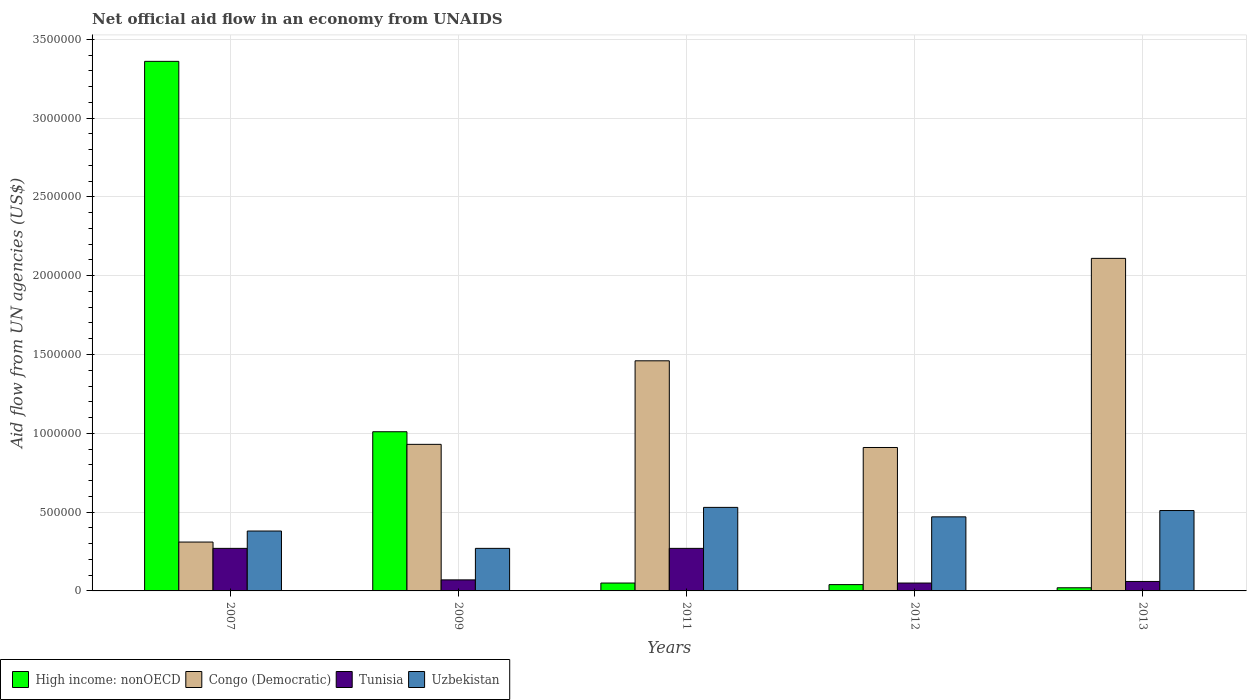How many different coloured bars are there?
Make the answer very short. 4. Are the number of bars per tick equal to the number of legend labels?
Give a very brief answer. Yes. How many bars are there on the 5th tick from the right?
Your answer should be compact. 4. In how many cases, is the number of bars for a given year not equal to the number of legend labels?
Provide a succinct answer. 0. What is the net official aid flow in Uzbekistan in 2009?
Provide a short and direct response. 2.70e+05. Across all years, what is the maximum net official aid flow in Congo (Democratic)?
Make the answer very short. 2.11e+06. Across all years, what is the minimum net official aid flow in Uzbekistan?
Offer a very short reply. 2.70e+05. In which year was the net official aid flow in Congo (Democratic) maximum?
Your response must be concise. 2013. What is the total net official aid flow in Uzbekistan in the graph?
Provide a short and direct response. 2.16e+06. What is the difference between the net official aid flow in Congo (Democratic) in 2009 and that in 2011?
Ensure brevity in your answer.  -5.30e+05. What is the difference between the net official aid flow in High income: nonOECD in 2007 and the net official aid flow in Congo (Democratic) in 2011?
Provide a short and direct response. 1.90e+06. What is the average net official aid flow in Uzbekistan per year?
Offer a terse response. 4.32e+05. What is the ratio of the net official aid flow in Congo (Democratic) in 2011 to that in 2013?
Ensure brevity in your answer.  0.69. What is the difference between the highest and the second highest net official aid flow in Congo (Democratic)?
Keep it short and to the point. 6.50e+05. What is the difference between the highest and the lowest net official aid flow in High income: nonOECD?
Your answer should be very brief. 3.34e+06. In how many years, is the net official aid flow in Uzbekistan greater than the average net official aid flow in Uzbekistan taken over all years?
Keep it short and to the point. 3. Is the sum of the net official aid flow in Congo (Democratic) in 2007 and 2012 greater than the maximum net official aid flow in Tunisia across all years?
Offer a terse response. Yes. Is it the case that in every year, the sum of the net official aid flow in Tunisia and net official aid flow in High income: nonOECD is greater than the sum of net official aid flow in Uzbekistan and net official aid flow in Congo (Democratic)?
Provide a succinct answer. No. What does the 4th bar from the left in 2009 represents?
Provide a short and direct response. Uzbekistan. What does the 3rd bar from the right in 2013 represents?
Make the answer very short. Congo (Democratic). How many bars are there?
Offer a very short reply. 20. What is the difference between two consecutive major ticks on the Y-axis?
Your answer should be very brief. 5.00e+05. Are the values on the major ticks of Y-axis written in scientific E-notation?
Provide a succinct answer. No. Does the graph contain grids?
Your answer should be very brief. Yes. Where does the legend appear in the graph?
Your response must be concise. Bottom left. What is the title of the graph?
Your answer should be compact. Net official aid flow in an economy from UNAIDS. Does "Botswana" appear as one of the legend labels in the graph?
Give a very brief answer. No. What is the label or title of the X-axis?
Provide a short and direct response. Years. What is the label or title of the Y-axis?
Your answer should be very brief. Aid flow from UN agencies (US$). What is the Aid flow from UN agencies (US$) in High income: nonOECD in 2007?
Offer a terse response. 3.36e+06. What is the Aid flow from UN agencies (US$) of High income: nonOECD in 2009?
Ensure brevity in your answer.  1.01e+06. What is the Aid flow from UN agencies (US$) of Congo (Democratic) in 2009?
Your answer should be compact. 9.30e+05. What is the Aid flow from UN agencies (US$) in Uzbekistan in 2009?
Make the answer very short. 2.70e+05. What is the Aid flow from UN agencies (US$) in Congo (Democratic) in 2011?
Your answer should be compact. 1.46e+06. What is the Aid flow from UN agencies (US$) of Tunisia in 2011?
Ensure brevity in your answer.  2.70e+05. What is the Aid flow from UN agencies (US$) of Uzbekistan in 2011?
Make the answer very short. 5.30e+05. What is the Aid flow from UN agencies (US$) of Congo (Democratic) in 2012?
Provide a short and direct response. 9.10e+05. What is the Aid flow from UN agencies (US$) of Uzbekistan in 2012?
Provide a succinct answer. 4.70e+05. What is the Aid flow from UN agencies (US$) of Congo (Democratic) in 2013?
Offer a very short reply. 2.11e+06. What is the Aid flow from UN agencies (US$) in Uzbekistan in 2013?
Give a very brief answer. 5.10e+05. Across all years, what is the maximum Aid flow from UN agencies (US$) in High income: nonOECD?
Give a very brief answer. 3.36e+06. Across all years, what is the maximum Aid flow from UN agencies (US$) of Congo (Democratic)?
Provide a short and direct response. 2.11e+06. Across all years, what is the maximum Aid flow from UN agencies (US$) of Uzbekistan?
Your answer should be very brief. 5.30e+05. Across all years, what is the minimum Aid flow from UN agencies (US$) of High income: nonOECD?
Offer a terse response. 2.00e+04. Across all years, what is the minimum Aid flow from UN agencies (US$) of Congo (Democratic)?
Offer a terse response. 3.10e+05. What is the total Aid flow from UN agencies (US$) of High income: nonOECD in the graph?
Give a very brief answer. 4.48e+06. What is the total Aid flow from UN agencies (US$) of Congo (Democratic) in the graph?
Your answer should be compact. 5.72e+06. What is the total Aid flow from UN agencies (US$) in Tunisia in the graph?
Provide a succinct answer. 7.20e+05. What is the total Aid flow from UN agencies (US$) of Uzbekistan in the graph?
Offer a terse response. 2.16e+06. What is the difference between the Aid flow from UN agencies (US$) of High income: nonOECD in 2007 and that in 2009?
Make the answer very short. 2.35e+06. What is the difference between the Aid flow from UN agencies (US$) in Congo (Democratic) in 2007 and that in 2009?
Make the answer very short. -6.20e+05. What is the difference between the Aid flow from UN agencies (US$) in Tunisia in 2007 and that in 2009?
Make the answer very short. 2.00e+05. What is the difference between the Aid flow from UN agencies (US$) in High income: nonOECD in 2007 and that in 2011?
Your answer should be very brief. 3.31e+06. What is the difference between the Aid flow from UN agencies (US$) in Congo (Democratic) in 2007 and that in 2011?
Provide a succinct answer. -1.15e+06. What is the difference between the Aid flow from UN agencies (US$) in Tunisia in 2007 and that in 2011?
Provide a short and direct response. 0. What is the difference between the Aid flow from UN agencies (US$) in Uzbekistan in 2007 and that in 2011?
Provide a succinct answer. -1.50e+05. What is the difference between the Aid flow from UN agencies (US$) of High income: nonOECD in 2007 and that in 2012?
Offer a terse response. 3.32e+06. What is the difference between the Aid flow from UN agencies (US$) in Congo (Democratic) in 2007 and that in 2012?
Give a very brief answer. -6.00e+05. What is the difference between the Aid flow from UN agencies (US$) of Tunisia in 2007 and that in 2012?
Ensure brevity in your answer.  2.20e+05. What is the difference between the Aid flow from UN agencies (US$) of High income: nonOECD in 2007 and that in 2013?
Give a very brief answer. 3.34e+06. What is the difference between the Aid flow from UN agencies (US$) of Congo (Democratic) in 2007 and that in 2013?
Offer a very short reply. -1.80e+06. What is the difference between the Aid flow from UN agencies (US$) of High income: nonOECD in 2009 and that in 2011?
Offer a terse response. 9.60e+05. What is the difference between the Aid flow from UN agencies (US$) in Congo (Democratic) in 2009 and that in 2011?
Offer a terse response. -5.30e+05. What is the difference between the Aid flow from UN agencies (US$) in Tunisia in 2009 and that in 2011?
Make the answer very short. -2.00e+05. What is the difference between the Aid flow from UN agencies (US$) in Uzbekistan in 2009 and that in 2011?
Keep it short and to the point. -2.60e+05. What is the difference between the Aid flow from UN agencies (US$) in High income: nonOECD in 2009 and that in 2012?
Your answer should be very brief. 9.70e+05. What is the difference between the Aid flow from UN agencies (US$) in Congo (Democratic) in 2009 and that in 2012?
Provide a succinct answer. 2.00e+04. What is the difference between the Aid flow from UN agencies (US$) of Tunisia in 2009 and that in 2012?
Offer a terse response. 2.00e+04. What is the difference between the Aid flow from UN agencies (US$) in Uzbekistan in 2009 and that in 2012?
Your response must be concise. -2.00e+05. What is the difference between the Aid flow from UN agencies (US$) of High income: nonOECD in 2009 and that in 2013?
Provide a short and direct response. 9.90e+05. What is the difference between the Aid flow from UN agencies (US$) of Congo (Democratic) in 2009 and that in 2013?
Your answer should be very brief. -1.18e+06. What is the difference between the Aid flow from UN agencies (US$) in Uzbekistan in 2009 and that in 2013?
Offer a terse response. -2.40e+05. What is the difference between the Aid flow from UN agencies (US$) of Tunisia in 2011 and that in 2012?
Your answer should be compact. 2.20e+05. What is the difference between the Aid flow from UN agencies (US$) of Uzbekistan in 2011 and that in 2012?
Give a very brief answer. 6.00e+04. What is the difference between the Aid flow from UN agencies (US$) in High income: nonOECD in 2011 and that in 2013?
Ensure brevity in your answer.  3.00e+04. What is the difference between the Aid flow from UN agencies (US$) in Congo (Democratic) in 2011 and that in 2013?
Provide a short and direct response. -6.50e+05. What is the difference between the Aid flow from UN agencies (US$) in Tunisia in 2011 and that in 2013?
Your answer should be very brief. 2.10e+05. What is the difference between the Aid flow from UN agencies (US$) in High income: nonOECD in 2012 and that in 2013?
Keep it short and to the point. 2.00e+04. What is the difference between the Aid flow from UN agencies (US$) in Congo (Democratic) in 2012 and that in 2013?
Provide a succinct answer. -1.20e+06. What is the difference between the Aid flow from UN agencies (US$) of Tunisia in 2012 and that in 2013?
Ensure brevity in your answer.  -10000. What is the difference between the Aid flow from UN agencies (US$) of High income: nonOECD in 2007 and the Aid flow from UN agencies (US$) of Congo (Democratic) in 2009?
Your answer should be very brief. 2.43e+06. What is the difference between the Aid flow from UN agencies (US$) of High income: nonOECD in 2007 and the Aid flow from UN agencies (US$) of Tunisia in 2009?
Give a very brief answer. 3.29e+06. What is the difference between the Aid flow from UN agencies (US$) of High income: nonOECD in 2007 and the Aid flow from UN agencies (US$) of Uzbekistan in 2009?
Offer a very short reply. 3.09e+06. What is the difference between the Aid flow from UN agencies (US$) of Congo (Democratic) in 2007 and the Aid flow from UN agencies (US$) of Uzbekistan in 2009?
Offer a very short reply. 4.00e+04. What is the difference between the Aid flow from UN agencies (US$) of High income: nonOECD in 2007 and the Aid flow from UN agencies (US$) of Congo (Democratic) in 2011?
Your response must be concise. 1.90e+06. What is the difference between the Aid flow from UN agencies (US$) in High income: nonOECD in 2007 and the Aid flow from UN agencies (US$) in Tunisia in 2011?
Provide a succinct answer. 3.09e+06. What is the difference between the Aid flow from UN agencies (US$) of High income: nonOECD in 2007 and the Aid flow from UN agencies (US$) of Uzbekistan in 2011?
Provide a short and direct response. 2.83e+06. What is the difference between the Aid flow from UN agencies (US$) of Congo (Democratic) in 2007 and the Aid flow from UN agencies (US$) of Uzbekistan in 2011?
Keep it short and to the point. -2.20e+05. What is the difference between the Aid flow from UN agencies (US$) of Tunisia in 2007 and the Aid flow from UN agencies (US$) of Uzbekistan in 2011?
Ensure brevity in your answer.  -2.60e+05. What is the difference between the Aid flow from UN agencies (US$) of High income: nonOECD in 2007 and the Aid flow from UN agencies (US$) of Congo (Democratic) in 2012?
Provide a short and direct response. 2.45e+06. What is the difference between the Aid flow from UN agencies (US$) of High income: nonOECD in 2007 and the Aid flow from UN agencies (US$) of Tunisia in 2012?
Your answer should be very brief. 3.31e+06. What is the difference between the Aid flow from UN agencies (US$) in High income: nonOECD in 2007 and the Aid flow from UN agencies (US$) in Uzbekistan in 2012?
Give a very brief answer. 2.89e+06. What is the difference between the Aid flow from UN agencies (US$) in Congo (Democratic) in 2007 and the Aid flow from UN agencies (US$) in Tunisia in 2012?
Give a very brief answer. 2.60e+05. What is the difference between the Aid flow from UN agencies (US$) in Congo (Democratic) in 2007 and the Aid flow from UN agencies (US$) in Uzbekistan in 2012?
Your response must be concise. -1.60e+05. What is the difference between the Aid flow from UN agencies (US$) of High income: nonOECD in 2007 and the Aid flow from UN agencies (US$) of Congo (Democratic) in 2013?
Provide a succinct answer. 1.25e+06. What is the difference between the Aid flow from UN agencies (US$) in High income: nonOECD in 2007 and the Aid flow from UN agencies (US$) in Tunisia in 2013?
Offer a very short reply. 3.30e+06. What is the difference between the Aid flow from UN agencies (US$) in High income: nonOECD in 2007 and the Aid flow from UN agencies (US$) in Uzbekistan in 2013?
Offer a very short reply. 2.85e+06. What is the difference between the Aid flow from UN agencies (US$) of Congo (Democratic) in 2007 and the Aid flow from UN agencies (US$) of Tunisia in 2013?
Ensure brevity in your answer.  2.50e+05. What is the difference between the Aid flow from UN agencies (US$) of High income: nonOECD in 2009 and the Aid flow from UN agencies (US$) of Congo (Democratic) in 2011?
Make the answer very short. -4.50e+05. What is the difference between the Aid flow from UN agencies (US$) in High income: nonOECD in 2009 and the Aid flow from UN agencies (US$) in Tunisia in 2011?
Offer a very short reply. 7.40e+05. What is the difference between the Aid flow from UN agencies (US$) of Congo (Democratic) in 2009 and the Aid flow from UN agencies (US$) of Tunisia in 2011?
Ensure brevity in your answer.  6.60e+05. What is the difference between the Aid flow from UN agencies (US$) of Tunisia in 2009 and the Aid flow from UN agencies (US$) of Uzbekistan in 2011?
Your answer should be very brief. -4.60e+05. What is the difference between the Aid flow from UN agencies (US$) of High income: nonOECD in 2009 and the Aid flow from UN agencies (US$) of Tunisia in 2012?
Keep it short and to the point. 9.60e+05. What is the difference between the Aid flow from UN agencies (US$) in High income: nonOECD in 2009 and the Aid flow from UN agencies (US$) in Uzbekistan in 2012?
Give a very brief answer. 5.40e+05. What is the difference between the Aid flow from UN agencies (US$) in Congo (Democratic) in 2009 and the Aid flow from UN agencies (US$) in Tunisia in 2012?
Provide a short and direct response. 8.80e+05. What is the difference between the Aid flow from UN agencies (US$) in Congo (Democratic) in 2009 and the Aid flow from UN agencies (US$) in Uzbekistan in 2012?
Ensure brevity in your answer.  4.60e+05. What is the difference between the Aid flow from UN agencies (US$) of Tunisia in 2009 and the Aid flow from UN agencies (US$) of Uzbekistan in 2012?
Provide a succinct answer. -4.00e+05. What is the difference between the Aid flow from UN agencies (US$) of High income: nonOECD in 2009 and the Aid flow from UN agencies (US$) of Congo (Democratic) in 2013?
Ensure brevity in your answer.  -1.10e+06. What is the difference between the Aid flow from UN agencies (US$) in High income: nonOECD in 2009 and the Aid flow from UN agencies (US$) in Tunisia in 2013?
Make the answer very short. 9.50e+05. What is the difference between the Aid flow from UN agencies (US$) of Congo (Democratic) in 2009 and the Aid flow from UN agencies (US$) of Tunisia in 2013?
Provide a succinct answer. 8.70e+05. What is the difference between the Aid flow from UN agencies (US$) in Congo (Democratic) in 2009 and the Aid flow from UN agencies (US$) in Uzbekistan in 2013?
Give a very brief answer. 4.20e+05. What is the difference between the Aid flow from UN agencies (US$) of Tunisia in 2009 and the Aid flow from UN agencies (US$) of Uzbekistan in 2013?
Provide a short and direct response. -4.40e+05. What is the difference between the Aid flow from UN agencies (US$) of High income: nonOECD in 2011 and the Aid flow from UN agencies (US$) of Congo (Democratic) in 2012?
Give a very brief answer. -8.60e+05. What is the difference between the Aid flow from UN agencies (US$) in High income: nonOECD in 2011 and the Aid flow from UN agencies (US$) in Uzbekistan in 2012?
Offer a very short reply. -4.20e+05. What is the difference between the Aid flow from UN agencies (US$) in Congo (Democratic) in 2011 and the Aid flow from UN agencies (US$) in Tunisia in 2012?
Provide a succinct answer. 1.41e+06. What is the difference between the Aid flow from UN agencies (US$) in Congo (Democratic) in 2011 and the Aid flow from UN agencies (US$) in Uzbekistan in 2012?
Your answer should be compact. 9.90e+05. What is the difference between the Aid flow from UN agencies (US$) in High income: nonOECD in 2011 and the Aid flow from UN agencies (US$) in Congo (Democratic) in 2013?
Your answer should be very brief. -2.06e+06. What is the difference between the Aid flow from UN agencies (US$) of High income: nonOECD in 2011 and the Aid flow from UN agencies (US$) of Tunisia in 2013?
Your answer should be very brief. -10000. What is the difference between the Aid flow from UN agencies (US$) of High income: nonOECD in 2011 and the Aid flow from UN agencies (US$) of Uzbekistan in 2013?
Offer a terse response. -4.60e+05. What is the difference between the Aid flow from UN agencies (US$) in Congo (Democratic) in 2011 and the Aid flow from UN agencies (US$) in Tunisia in 2013?
Make the answer very short. 1.40e+06. What is the difference between the Aid flow from UN agencies (US$) in Congo (Democratic) in 2011 and the Aid flow from UN agencies (US$) in Uzbekistan in 2013?
Make the answer very short. 9.50e+05. What is the difference between the Aid flow from UN agencies (US$) in High income: nonOECD in 2012 and the Aid flow from UN agencies (US$) in Congo (Democratic) in 2013?
Provide a short and direct response. -2.07e+06. What is the difference between the Aid flow from UN agencies (US$) of High income: nonOECD in 2012 and the Aid flow from UN agencies (US$) of Uzbekistan in 2013?
Give a very brief answer. -4.70e+05. What is the difference between the Aid flow from UN agencies (US$) of Congo (Democratic) in 2012 and the Aid flow from UN agencies (US$) of Tunisia in 2013?
Your answer should be very brief. 8.50e+05. What is the difference between the Aid flow from UN agencies (US$) in Tunisia in 2012 and the Aid flow from UN agencies (US$) in Uzbekistan in 2013?
Make the answer very short. -4.60e+05. What is the average Aid flow from UN agencies (US$) in High income: nonOECD per year?
Provide a short and direct response. 8.96e+05. What is the average Aid flow from UN agencies (US$) of Congo (Democratic) per year?
Give a very brief answer. 1.14e+06. What is the average Aid flow from UN agencies (US$) of Tunisia per year?
Provide a succinct answer. 1.44e+05. What is the average Aid flow from UN agencies (US$) of Uzbekistan per year?
Give a very brief answer. 4.32e+05. In the year 2007, what is the difference between the Aid flow from UN agencies (US$) of High income: nonOECD and Aid flow from UN agencies (US$) of Congo (Democratic)?
Your answer should be compact. 3.05e+06. In the year 2007, what is the difference between the Aid flow from UN agencies (US$) of High income: nonOECD and Aid flow from UN agencies (US$) of Tunisia?
Your response must be concise. 3.09e+06. In the year 2007, what is the difference between the Aid flow from UN agencies (US$) of High income: nonOECD and Aid flow from UN agencies (US$) of Uzbekistan?
Your answer should be very brief. 2.98e+06. In the year 2007, what is the difference between the Aid flow from UN agencies (US$) of Congo (Democratic) and Aid flow from UN agencies (US$) of Tunisia?
Give a very brief answer. 4.00e+04. In the year 2007, what is the difference between the Aid flow from UN agencies (US$) of Congo (Democratic) and Aid flow from UN agencies (US$) of Uzbekistan?
Give a very brief answer. -7.00e+04. In the year 2007, what is the difference between the Aid flow from UN agencies (US$) of Tunisia and Aid flow from UN agencies (US$) of Uzbekistan?
Offer a very short reply. -1.10e+05. In the year 2009, what is the difference between the Aid flow from UN agencies (US$) of High income: nonOECD and Aid flow from UN agencies (US$) of Tunisia?
Keep it short and to the point. 9.40e+05. In the year 2009, what is the difference between the Aid flow from UN agencies (US$) of High income: nonOECD and Aid flow from UN agencies (US$) of Uzbekistan?
Provide a short and direct response. 7.40e+05. In the year 2009, what is the difference between the Aid flow from UN agencies (US$) of Congo (Democratic) and Aid flow from UN agencies (US$) of Tunisia?
Offer a very short reply. 8.60e+05. In the year 2009, what is the difference between the Aid flow from UN agencies (US$) of Congo (Democratic) and Aid flow from UN agencies (US$) of Uzbekistan?
Your answer should be very brief. 6.60e+05. In the year 2011, what is the difference between the Aid flow from UN agencies (US$) in High income: nonOECD and Aid flow from UN agencies (US$) in Congo (Democratic)?
Give a very brief answer. -1.41e+06. In the year 2011, what is the difference between the Aid flow from UN agencies (US$) in High income: nonOECD and Aid flow from UN agencies (US$) in Tunisia?
Your answer should be very brief. -2.20e+05. In the year 2011, what is the difference between the Aid flow from UN agencies (US$) of High income: nonOECD and Aid flow from UN agencies (US$) of Uzbekistan?
Your response must be concise. -4.80e+05. In the year 2011, what is the difference between the Aid flow from UN agencies (US$) of Congo (Democratic) and Aid flow from UN agencies (US$) of Tunisia?
Your answer should be compact. 1.19e+06. In the year 2011, what is the difference between the Aid flow from UN agencies (US$) of Congo (Democratic) and Aid flow from UN agencies (US$) of Uzbekistan?
Provide a short and direct response. 9.30e+05. In the year 2011, what is the difference between the Aid flow from UN agencies (US$) in Tunisia and Aid flow from UN agencies (US$) in Uzbekistan?
Your answer should be compact. -2.60e+05. In the year 2012, what is the difference between the Aid flow from UN agencies (US$) in High income: nonOECD and Aid flow from UN agencies (US$) in Congo (Democratic)?
Make the answer very short. -8.70e+05. In the year 2012, what is the difference between the Aid flow from UN agencies (US$) of High income: nonOECD and Aid flow from UN agencies (US$) of Uzbekistan?
Give a very brief answer. -4.30e+05. In the year 2012, what is the difference between the Aid flow from UN agencies (US$) in Congo (Democratic) and Aid flow from UN agencies (US$) in Tunisia?
Offer a terse response. 8.60e+05. In the year 2012, what is the difference between the Aid flow from UN agencies (US$) in Congo (Democratic) and Aid flow from UN agencies (US$) in Uzbekistan?
Make the answer very short. 4.40e+05. In the year 2012, what is the difference between the Aid flow from UN agencies (US$) of Tunisia and Aid flow from UN agencies (US$) of Uzbekistan?
Your answer should be compact. -4.20e+05. In the year 2013, what is the difference between the Aid flow from UN agencies (US$) of High income: nonOECD and Aid flow from UN agencies (US$) of Congo (Democratic)?
Your answer should be compact. -2.09e+06. In the year 2013, what is the difference between the Aid flow from UN agencies (US$) in High income: nonOECD and Aid flow from UN agencies (US$) in Tunisia?
Provide a succinct answer. -4.00e+04. In the year 2013, what is the difference between the Aid flow from UN agencies (US$) in High income: nonOECD and Aid flow from UN agencies (US$) in Uzbekistan?
Your response must be concise. -4.90e+05. In the year 2013, what is the difference between the Aid flow from UN agencies (US$) in Congo (Democratic) and Aid flow from UN agencies (US$) in Tunisia?
Offer a very short reply. 2.05e+06. In the year 2013, what is the difference between the Aid flow from UN agencies (US$) of Congo (Democratic) and Aid flow from UN agencies (US$) of Uzbekistan?
Offer a terse response. 1.60e+06. In the year 2013, what is the difference between the Aid flow from UN agencies (US$) of Tunisia and Aid flow from UN agencies (US$) of Uzbekistan?
Your answer should be very brief. -4.50e+05. What is the ratio of the Aid flow from UN agencies (US$) of High income: nonOECD in 2007 to that in 2009?
Give a very brief answer. 3.33. What is the ratio of the Aid flow from UN agencies (US$) of Congo (Democratic) in 2007 to that in 2009?
Make the answer very short. 0.33. What is the ratio of the Aid flow from UN agencies (US$) in Tunisia in 2007 to that in 2009?
Your answer should be compact. 3.86. What is the ratio of the Aid flow from UN agencies (US$) of Uzbekistan in 2007 to that in 2009?
Your response must be concise. 1.41. What is the ratio of the Aid flow from UN agencies (US$) of High income: nonOECD in 2007 to that in 2011?
Provide a short and direct response. 67.2. What is the ratio of the Aid flow from UN agencies (US$) of Congo (Democratic) in 2007 to that in 2011?
Give a very brief answer. 0.21. What is the ratio of the Aid flow from UN agencies (US$) in Uzbekistan in 2007 to that in 2011?
Give a very brief answer. 0.72. What is the ratio of the Aid flow from UN agencies (US$) in High income: nonOECD in 2007 to that in 2012?
Give a very brief answer. 84. What is the ratio of the Aid flow from UN agencies (US$) of Congo (Democratic) in 2007 to that in 2012?
Your answer should be compact. 0.34. What is the ratio of the Aid flow from UN agencies (US$) of Uzbekistan in 2007 to that in 2012?
Your answer should be compact. 0.81. What is the ratio of the Aid flow from UN agencies (US$) in High income: nonOECD in 2007 to that in 2013?
Your answer should be very brief. 168. What is the ratio of the Aid flow from UN agencies (US$) of Congo (Democratic) in 2007 to that in 2013?
Your answer should be very brief. 0.15. What is the ratio of the Aid flow from UN agencies (US$) in Uzbekistan in 2007 to that in 2013?
Offer a terse response. 0.75. What is the ratio of the Aid flow from UN agencies (US$) of High income: nonOECD in 2009 to that in 2011?
Keep it short and to the point. 20.2. What is the ratio of the Aid flow from UN agencies (US$) in Congo (Democratic) in 2009 to that in 2011?
Offer a terse response. 0.64. What is the ratio of the Aid flow from UN agencies (US$) of Tunisia in 2009 to that in 2011?
Your answer should be very brief. 0.26. What is the ratio of the Aid flow from UN agencies (US$) in Uzbekistan in 2009 to that in 2011?
Your answer should be very brief. 0.51. What is the ratio of the Aid flow from UN agencies (US$) in High income: nonOECD in 2009 to that in 2012?
Provide a succinct answer. 25.25. What is the ratio of the Aid flow from UN agencies (US$) of Uzbekistan in 2009 to that in 2012?
Your response must be concise. 0.57. What is the ratio of the Aid flow from UN agencies (US$) of High income: nonOECD in 2009 to that in 2013?
Ensure brevity in your answer.  50.5. What is the ratio of the Aid flow from UN agencies (US$) of Congo (Democratic) in 2009 to that in 2013?
Your answer should be compact. 0.44. What is the ratio of the Aid flow from UN agencies (US$) in Uzbekistan in 2009 to that in 2013?
Offer a terse response. 0.53. What is the ratio of the Aid flow from UN agencies (US$) of Congo (Democratic) in 2011 to that in 2012?
Keep it short and to the point. 1.6. What is the ratio of the Aid flow from UN agencies (US$) of Tunisia in 2011 to that in 2012?
Your answer should be compact. 5.4. What is the ratio of the Aid flow from UN agencies (US$) in Uzbekistan in 2011 to that in 2012?
Offer a terse response. 1.13. What is the ratio of the Aid flow from UN agencies (US$) in High income: nonOECD in 2011 to that in 2013?
Your response must be concise. 2.5. What is the ratio of the Aid flow from UN agencies (US$) of Congo (Democratic) in 2011 to that in 2013?
Offer a very short reply. 0.69. What is the ratio of the Aid flow from UN agencies (US$) of Uzbekistan in 2011 to that in 2013?
Make the answer very short. 1.04. What is the ratio of the Aid flow from UN agencies (US$) in High income: nonOECD in 2012 to that in 2013?
Your response must be concise. 2. What is the ratio of the Aid flow from UN agencies (US$) in Congo (Democratic) in 2012 to that in 2013?
Offer a very short reply. 0.43. What is the ratio of the Aid flow from UN agencies (US$) of Tunisia in 2012 to that in 2013?
Your answer should be compact. 0.83. What is the ratio of the Aid flow from UN agencies (US$) of Uzbekistan in 2012 to that in 2013?
Keep it short and to the point. 0.92. What is the difference between the highest and the second highest Aid flow from UN agencies (US$) of High income: nonOECD?
Keep it short and to the point. 2.35e+06. What is the difference between the highest and the second highest Aid flow from UN agencies (US$) of Congo (Democratic)?
Provide a succinct answer. 6.50e+05. What is the difference between the highest and the lowest Aid flow from UN agencies (US$) in High income: nonOECD?
Offer a very short reply. 3.34e+06. What is the difference between the highest and the lowest Aid flow from UN agencies (US$) of Congo (Democratic)?
Provide a succinct answer. 1.80e+06. What is the difference between the highest and the lowest Aid flow from UN agencies (US$) of Uzbekistan?
Your answer should be very brief. 2.60e+05. 